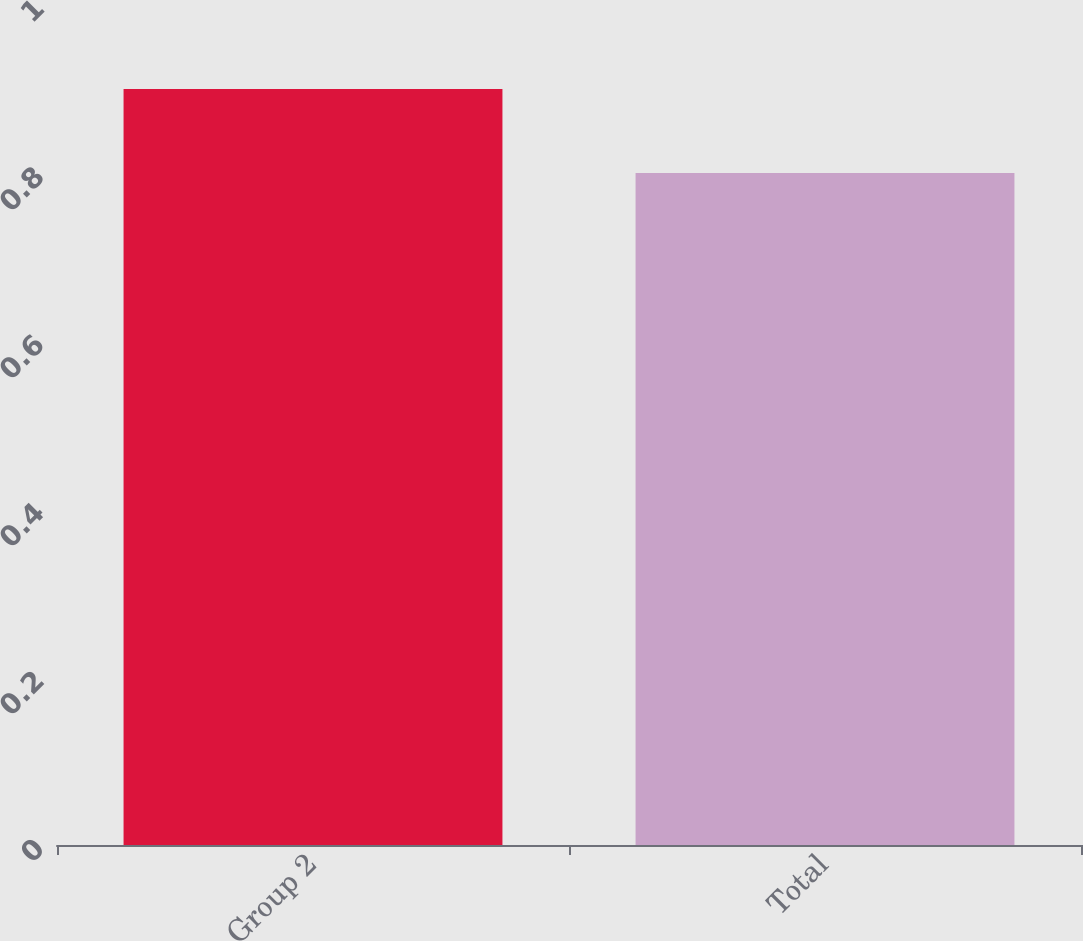Convert chart. <chart><loc_0><loc_0><loc_500><loc_500><bar_chart><fcel>Group 2<fcel>Total<nl><fcel>0.9<fcel>0.8<nl></chart> 